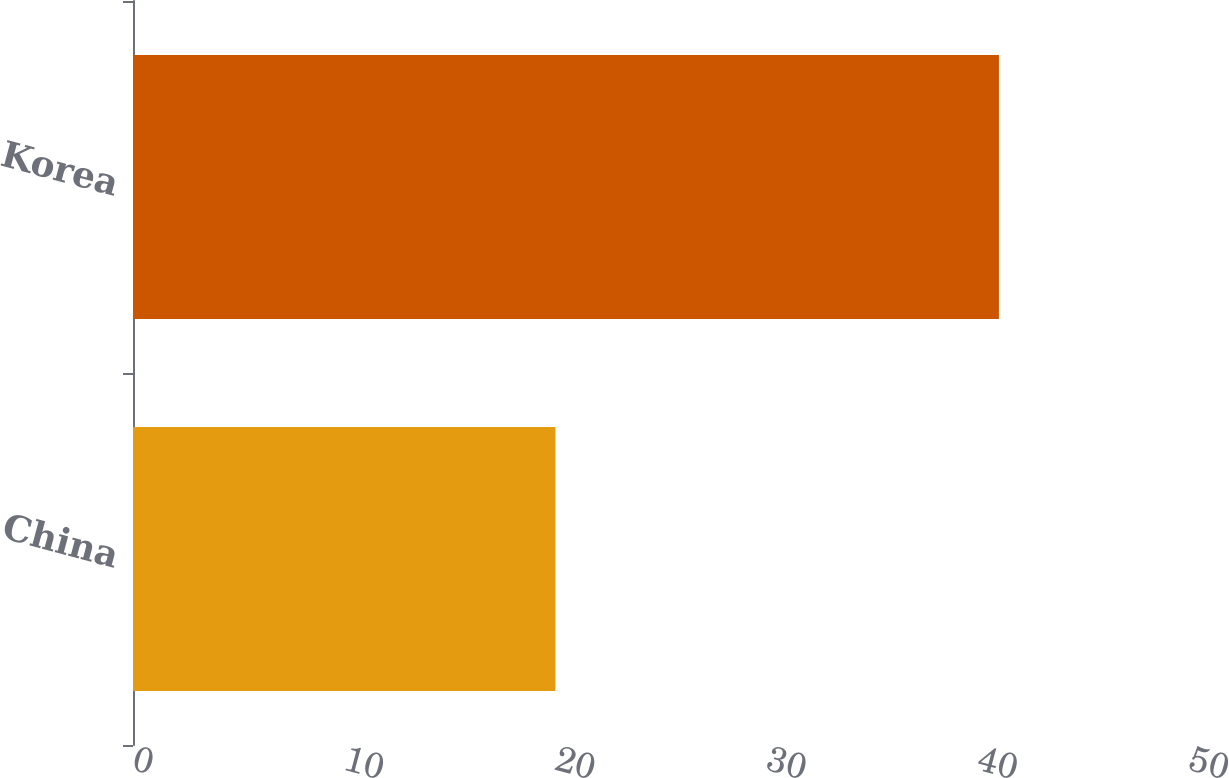Convert chart. <chart><loc_0><loc_0><loc_500><loc_500><bar_chart><fcel>China<fcel>Korea<nl><fcel>20<fcel>41<nl></chart> 